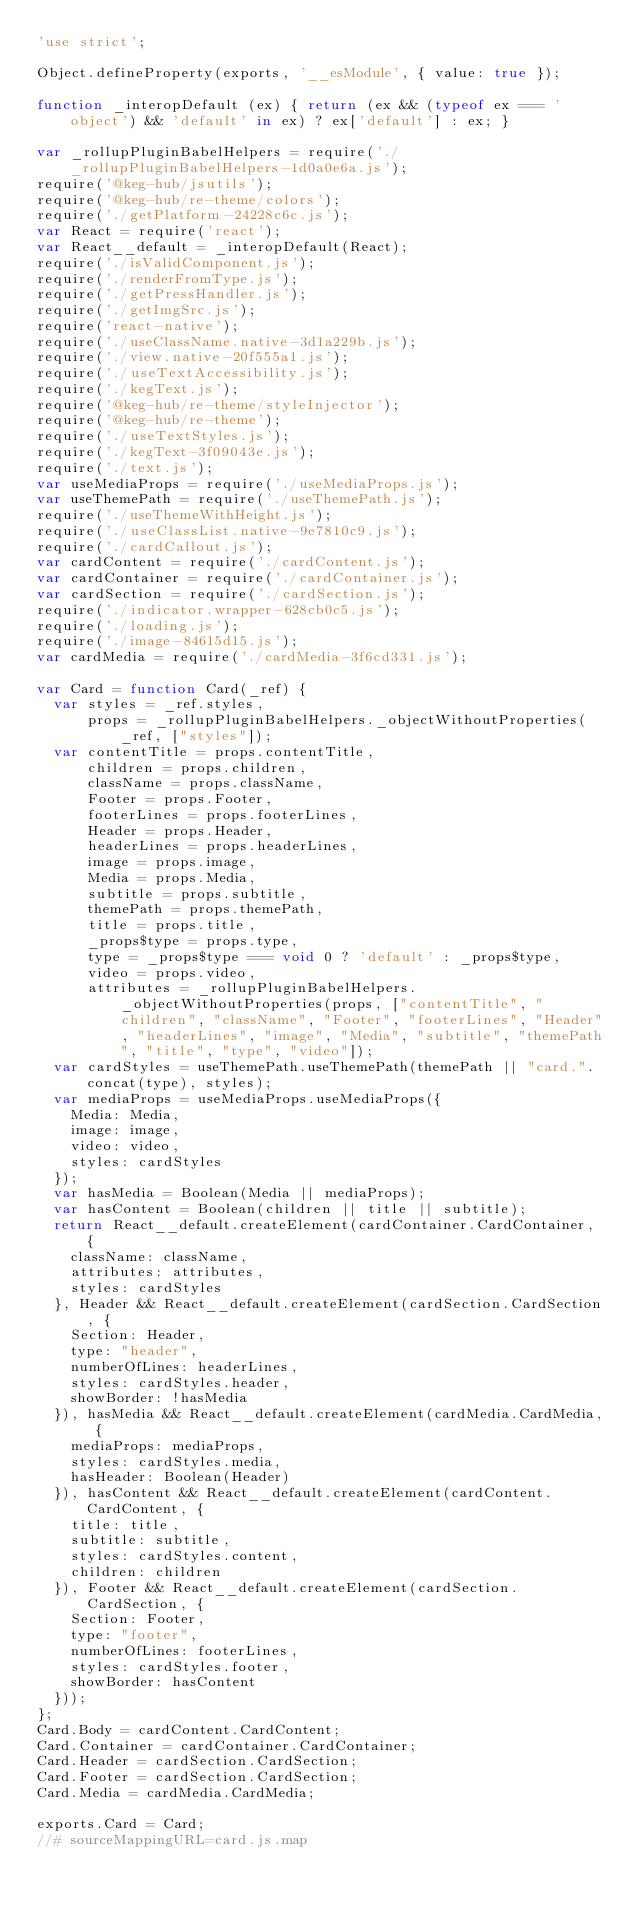<code> <loc_0><loc_0><loc_500><loc_500><_JavaScript_>'use strict';

Object.defineProperty(exports, '__esModule', { value: true });

function _interopDefault (ex) { return (ex && (typeof ex === 'object') && 'default' in ex) ? ex['default'] : ex; }

var _rollupPluginBabelHelpers = require('./_rollupPluginBabelHelpers-1d0a0e6a.js');
require('@keg-hub/jsutils');
require('@keg-hub/re-theme/colors');
require('./getPlatform-24228c6c.js');
var React = require('react');
var React__default = _interopDefault(React);
require('./isValidComponent.js');
require('./renderFromType.js');
require('./getPressHandler.js');
require('./getImgSrc.js');
require('react-native');
require('./useClassName.native-3d1a229b.js');
require('./view.native-20f555a1.js');
require('./useTextAccessibility.js');
require('./kegText.js');
require('@keg-hub/re-theme/styleInjector');
require('@keg-hub/re-theme');
require('./useTextStyles.js');
require('./kegText-3f09043e.js');
require('./text.js');
var useMediaProps = require('./useMediaProps.js');
var useThemePath = require('./useThemePath.js');
require('./useThemeWithHeight.js');
require('./useClassList.native-9e7810c9.js');
require('./cardCallout.js');
var cardContent = require('./cardContent.js');
var cardContainer = require('./cardContainer.js');
var cardSection = require('./cardSection.js');
require('./indicator.wrapper-628cb0c5.js');
require('./loading.js');
require('./image-84615d15.js');
var cardMedia = require('./cardMedia-3f6cd331.js');

var Card = function Card(_ref) {
  var styles = _ref.styles,
      props = _rollupPluginBabelHelpers._objectWithoutProperties(_ref, ["styles"]);
  var contentTitle = props.contentTitle,
      children = props.children,
      className = props.className,
      Footer = props.Footer,
      footerLines = props.footerLines,
      Header = props.Header,
      headerLines = props.headerLines,
      image = props.image,
      Media = props.Media,
      subtitle = props.subtitle,
      themePath = props.themePath,
      title = props.title,
      _props$type = props.type,
      type = _props$type === void 0 ? 'default' : _props$type,
      video = props.video,
      attributes = _rollupPluginBabelHelpers._objectWithoutProperties(props, ["contentTitle", "children", "className", "Footer", "footerLines", "Header", "headerLines", "image", "Media", "subtitle", "themePath", "title", "type", "video"]);
  var cardStyles = useThemePath.useThemePath(themePath || "card.".concat(type), styles);
  var mediaProps = useMediaProps.useMediaProps({
    Media: Media,
    image: image,
    video: video,
    styles: cardStyles
  });
  var hasMedia = Boolean(Media || mediaProps);
  var hasContent = Boolean(children || title || subtitle);
  return React__default.createElement(cardContainer.CardContainer, {
    className: className,
    attributes: attributes,
    styles: cardStyles
  }, Header && React__default.createElement(cardSection.CardSection, {
    Section: Header,
    type: "header",
    numberOfLines: headerLines,
    styles: cardStyles.header,
    showBorder: !hasMedia
  }), hasMedia && React__default.createElement(cardMedia.CardMedia, {
    mediaProps: mediaProps,
    styles: cardStyles.media,
    hasHeader: Boolean(Header)
  }), hasContent && React__default.createElement(cardContent.CardContent, {
    title: title,
    subtitle: subtitle,
    styles: cardStyles.content,
    children: children
  }), Footer && React__default.createElement(cardSection.CardSection, {
    Section: Footer,
    type: "footer",
    numberOfLines: footerLines,
    styles: cardStyles.footer,
    showBorder: hasContent
  }));
};
Card.Body = cardContent.CardContent;
Card.Container = cardContainer.CardContainer;
Card.Header = cardSection.CardSection;
Card.Footer = cardSection.CardSection;
Card.Media = cardMedia.CardMedia;

exports.Card = Card;
//# sourceMappingURL=card.js.map
</code> 